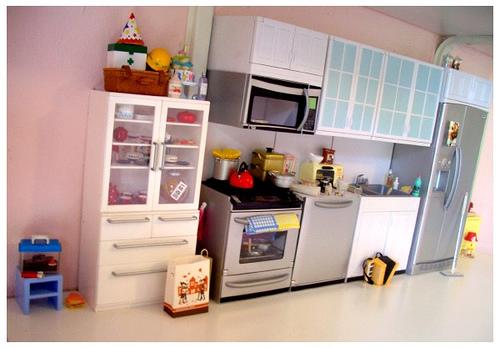Are there any children in this photo?
Keep it brief. No. Do any children live in this home?
Keep it brief. Yes. What room is this?
Quick response, please. Kitchen. 